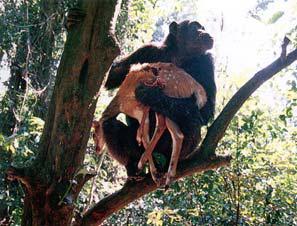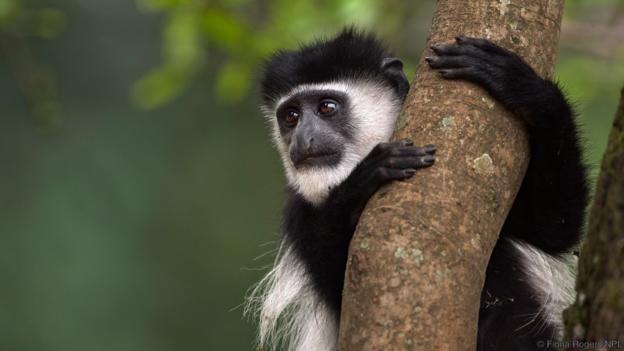The first image is the image on the left, the second image is the image on the right. Examine the images to the left and right. Is the description "An image shows at least three chimps huddled around a piece of carcass." accurate? Answer yes or no. No. The first image is the image on the left, the second image is the image on the right. Analyze the images presented: Is the assertion "A group of monkeys is eating meat in one of the images." valid? Answer yes or no. No. 